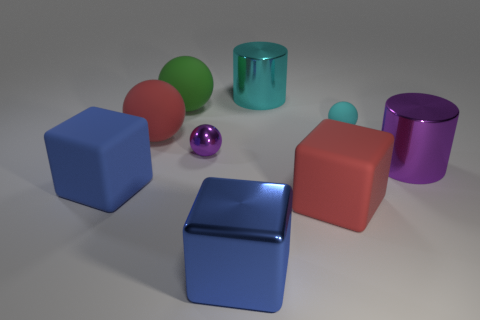Are the small cyan object and the cyan thing behind the small cyan rubber sphere made of the same material? While both objects are cyan, they do not appear to be made of the same material. The small cyan rubber sphere has a matte and slightly textured surface typical of rubber, while the cyan object behind it appears to have a metallic gloss and smooth surface, indicative of a different material, possibly metal or plastic. 